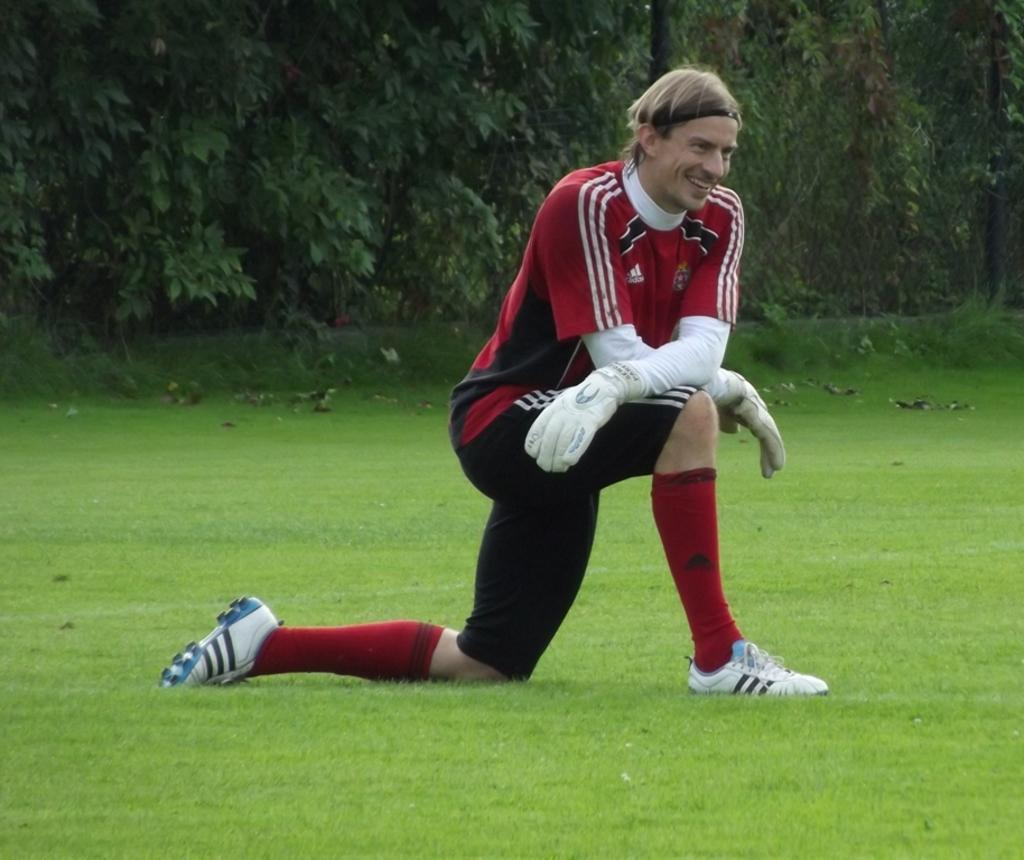Who is present in the image? There is a man in the image. What is the man doing in the image? The man is sitting on the grass. What is the man wearing on his upper body? The man is wearing a red T-shirt. What type of footwear is the man wearing? The man is wearing shoes. What can be seen in the background of the image? There is a tree in the background of the image. What color is the paint on the man's shoes in the image? There is no mention of paint on the man's shoes in the image, and the color of the shoes is not specified. 